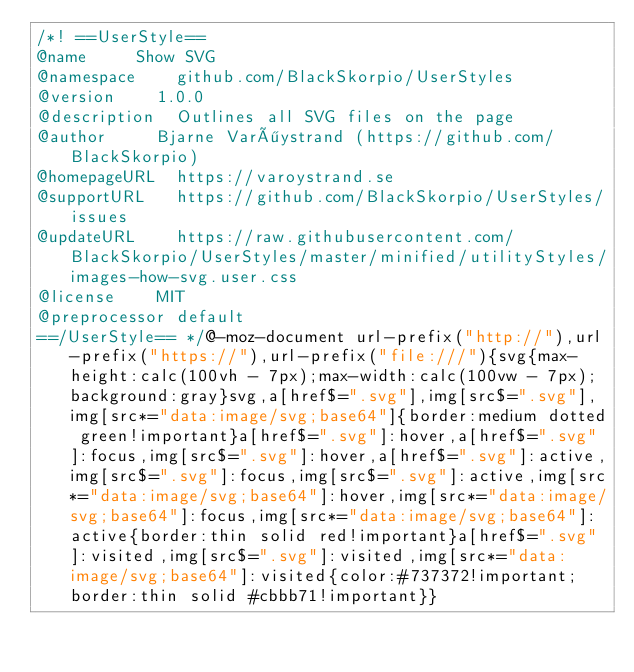<code> <loc_0><loc_0><loc_500><loc_500><_CSS_>/*! ==UserStyle==
@name			Show SVG
@namespace		github.com/BlackSkorpio/UserStyles
@version		1.0.0
@description	Outlines all SVG files on the page
@author			Bjarne Varöystrand (https://github.com/BlackSkorpio)
@homepageURL	https://varoystrand.se
@supportURL		https://github.com/BlackSkorpio/UserStyles/issues
@updateURL		https://raw.githubusercontent.com/BlackSkorpio/UserStyles/master/minified/utilityStyles/images-how-svg.user.css
@license		MIT
@preprocessor	default
==/UserStyle== */@-moz-document url-prefix("http://"),url-prefix("https://"),url-prefix("file:///"){svg{max-height:calc(100vh - 7px);max-width:calc(100vw - 7px);background:gray}svg,a[href$=".svg"],img[src$=".svg"],img[src*="data:image/svg;base64"]{border:medium dotted green!important}a[href$=".svg"]:hover,a[href$=".svg"]:focus,img[src$=".svg"]:hover,a[href$=".svg"]:active,img[src$=".svg"]:focus,img[src$=".svg"]:active,img[src*="data:image/svg;base64"]:hover,img[src*="data:image/svg;base64"]:focus,img[src*="data:image/svg;base64"]:active{border:thin solid red!important}a[href$=".svg"]:visited,img[src$=".svg"]:visited,img[src*="data:image/svg;base64"]:visited{color:#737372!important;border:thin solid #cbbb71!important}}</code> 